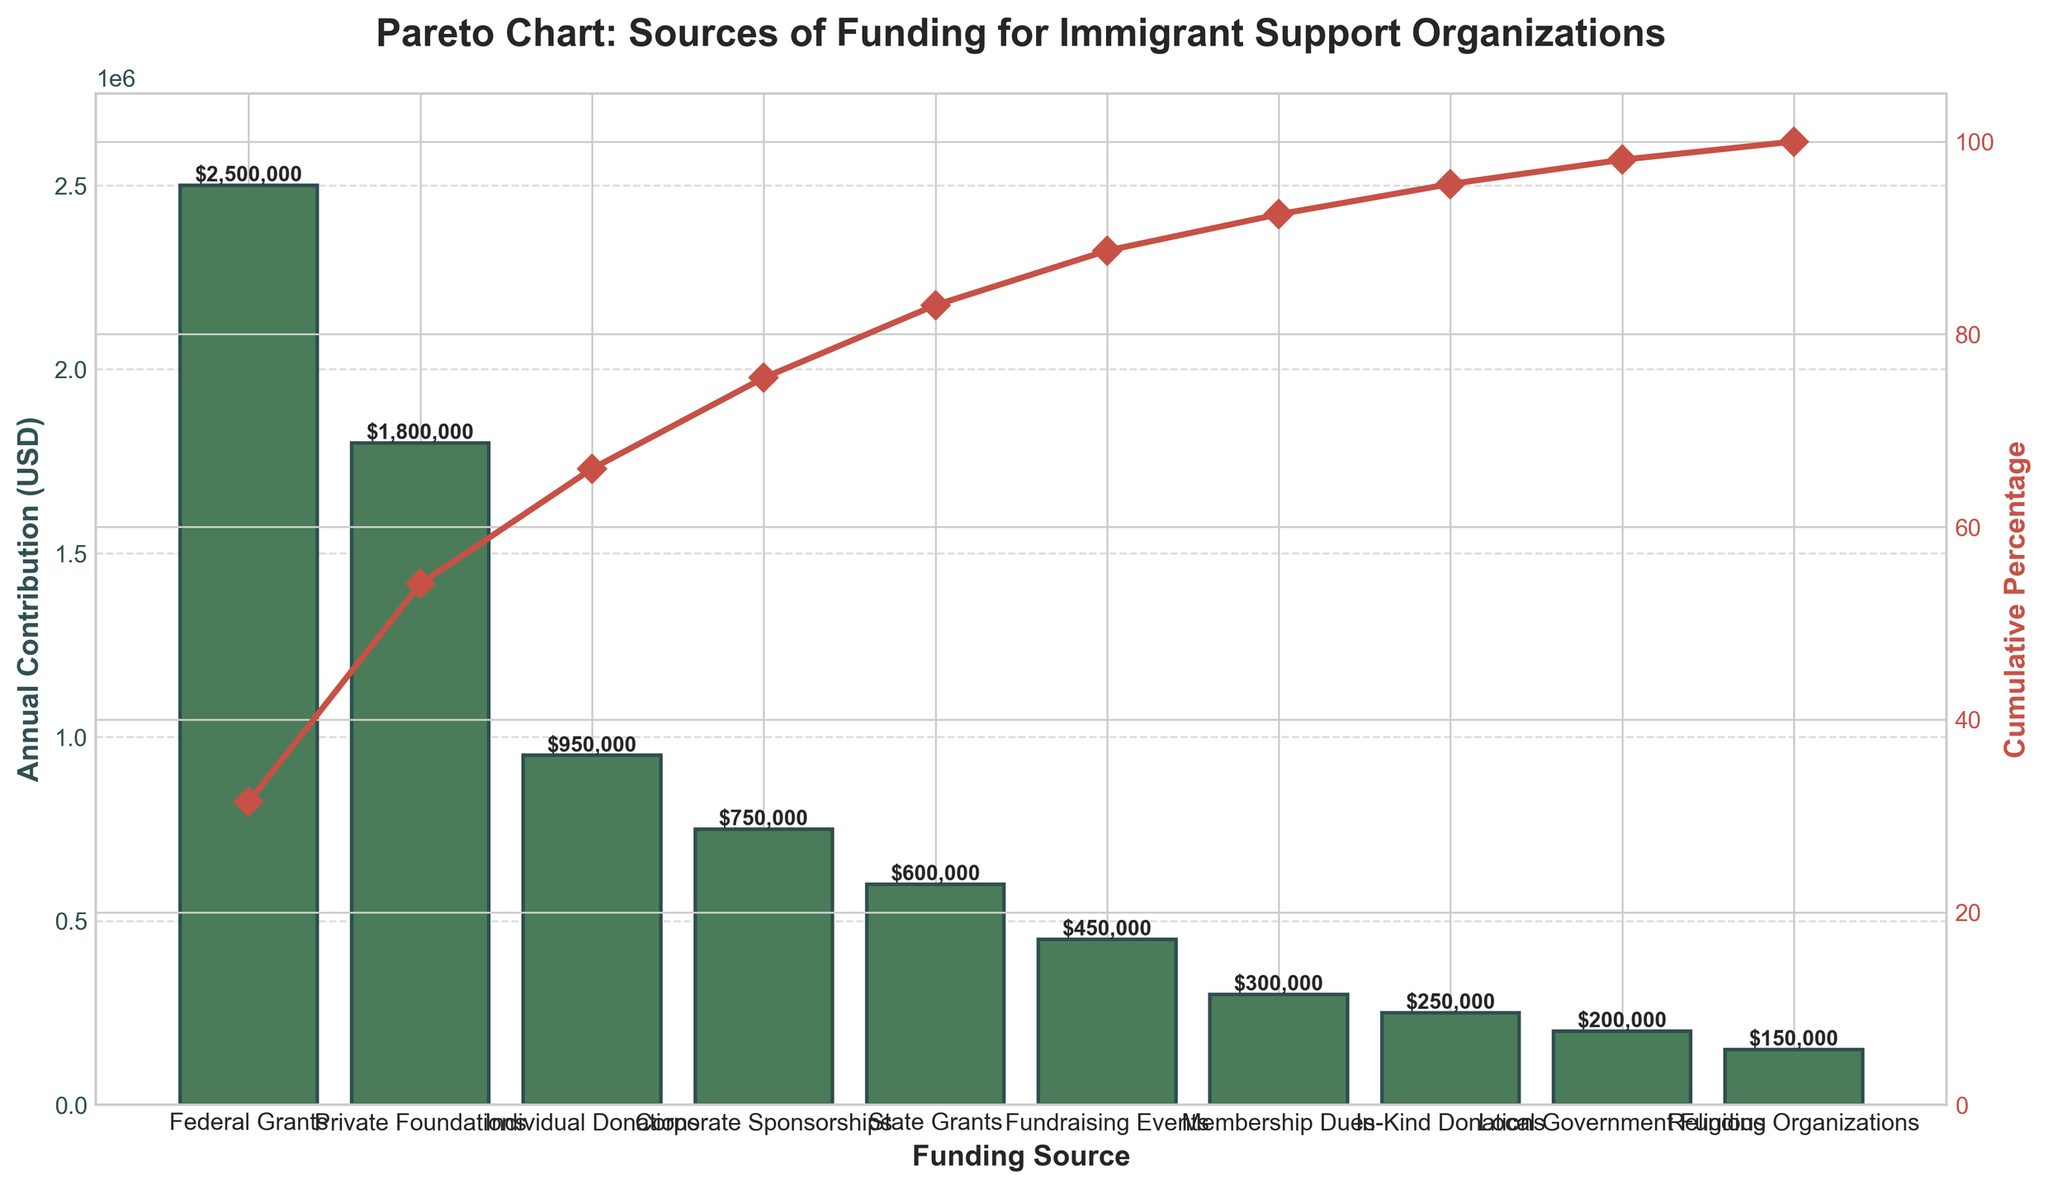How many funding sources are illustrated in the Pareto Chart? Count the number of unique categories along the x-axis to identify each funding source represented in the chart.
Answer: 10 Which funding source contributes the highest amount annually to immigrant support organizations? Identify the first bar in the chart, as the bars are sorted in descending order of annual contribution.
Answer: Federal Grants What is the cumulative percentage of funding from Federal Grants and Private Foundations? Look at the cumulative percentage line (red line) after the bar representing Private Foundations, which is the second bar.
Answer: 53% How much more does Federal Grants contribute compared to Individual Donations? Find the height (value) of the bars for Federal Grants and Individual Donations, subtract the latter from the former ($2,500,000 - $950,000).
Answer: $1,550,000 Which funding source contributes the least amount annually, and what is its contribution? Identify the last bar in the chart, which represents the smallest annual contribution, and note its value.
Answer: Religious Organizations, $150,000 Are Private Foundations contributing more than twice the amount of Local Government Funding? Compare the bar height for Private Foundations with twice the bar height for Local Government Funding. $1,800,000 > 2 × $200,000, so this is true.
Answer: Yes What is the combined annual contribution of Corporate Sponsorships and State Grants? Sum the values of the Corporate Sponsorships and State Grants bars ($750,000 + $600,000).
Answer: $1,350,000 Which funding sources contribute more than 10% each to the total annual contributions? Identify the bars with values whose heights contribute to more than 10% of the total, then compare each with $725,000 (since 10% of the total $7,250,000 is $725,000).
Answer: Federal Grants, Private Foundations, Individual Donations, Corporate Sponsorships 